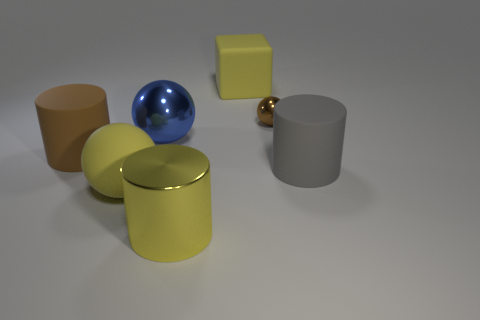How many other things are the same size as the brown cylinder?
Your response must be concise. 5. The big rubber block has what color?
Offer a very short reply. Yellow. What number of big objects are either yellow shiny cylinders or yellow matte balls?
Keep it short and to the point. 2. Is the size of the rubber cylinder to the right of the large brown thing the same as the yellow rubber thing that is in front of the tiny brown ball?
Your response must be concise. Yes. There is a brown shiny object that is the same shape as the large blue shiny thing; what is its size?
Provide a short and direct response. Small. Is the number of yellow things that are behind the big metal sphere greater than the number of brown metallic things that are in front of the small brown metallic object?
Ensure brevity in your answer.  Yes. There is a ball that is left of the small metal thing and behind the gray rubber cylinder; what material is it?
Provide a succinct answer. Metal. What is the color of the other large rubber object that is the same shape as the blue thing?
Make the answer very short. Yellow. The rubber ball has what size?
Offer a very short reply. Large. There is a big metal object that is behind the rubber object that is right of the block; what is its color?
Offer a terse response. Blue. 